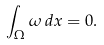Convert formula to latex. <formula><loc_0><loc_0><loc_500><loc_500>\int _ { \Omega } \omega \, d x = 0 .</formula> 